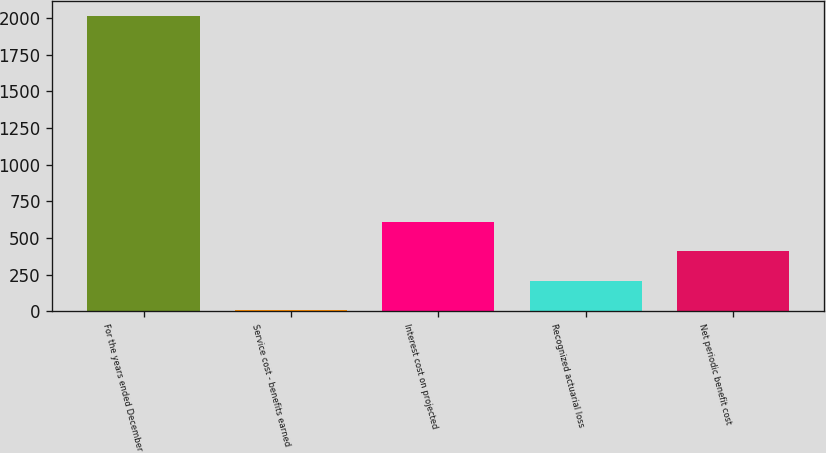Convert chart. <chart><loc_0><loc_0><loc_500><loc_500><bar_chart><fcel>For the years ended December<fcel>Service cost - benefits earned<fcel>Interest cost on projected<fcel>Recognized actuarial loss<fcel>Net periodic benefit cost<nl><fcel>2017<fcel>6<fcel>609.3<fcel>207.1<fcel>408.2<nl></chart> 